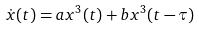Convert formula to latex. <formula><loc_0><loc_0><loc_500><loc_500>\dot { x } ( t ) = a x ^ { 3 } ( t ) + b x ^ { 3 } ( t - \tau )</formula> 